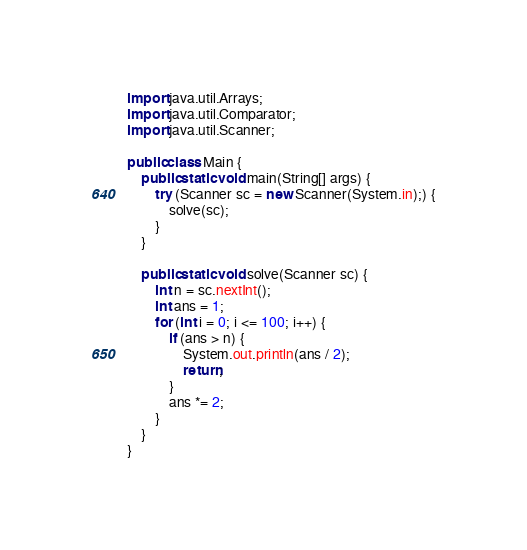Convert code to text. <code><loc_0><loc_0><loc_500><loc_500><_Java_>import java.util.Arrays;
import java.util.Comparator;
import java.util.Scanner;

public class Main {
    public static void main(String[] args) {
        try (Scanner sc = new Scanner(System.in);) {
            solve(sc);
        }
    }

    public static void solve(Scanner sc) {
        int n = sc.nextInt();
        int ans = 1;
        for (int i = 0; i <= 100; i++) {
            if (ans > n) {
                System.out.println(ans / 2);
                return;
            }
            ans *= 2;
        }
    }
}</code> 